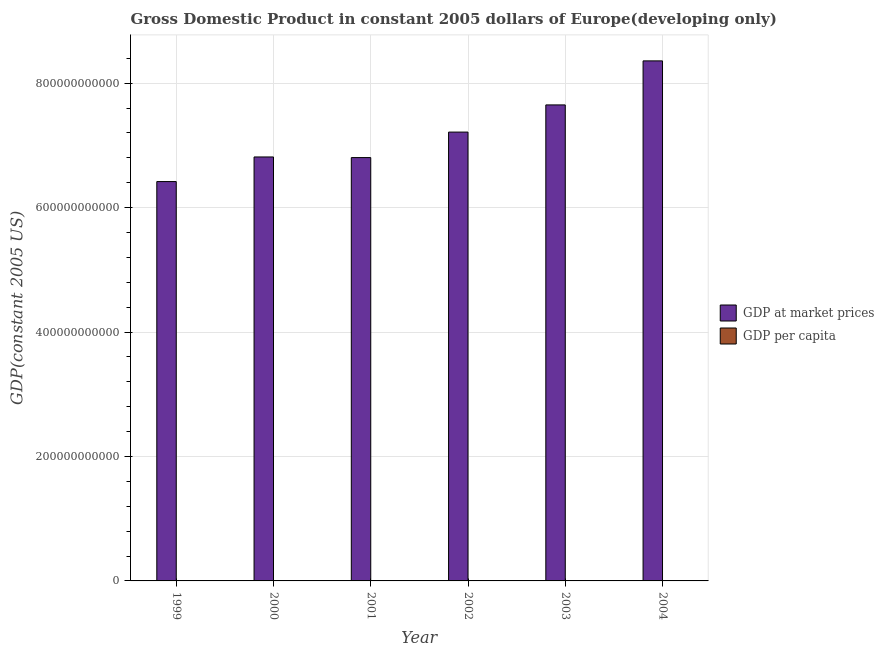How many groups of bars are there?
Keep it short and to the point. 6. Are the number of bars per tick equal to the number of legend labels?
Offer a terse response. Yes. Are the number of bars on each tick of the X-axis equal?
Offer a terse response. Yes. What is the label of the 1st group of bars from the left?
Your answer should be very brief. 1999. In how many cases, is the number of bars for a given year not equal to the number of legend labels?
Ensure brevity in your answer.  0. What is the gdp at market prices in 2003?
Offer a terse response. 7.65e+11. Across all years, what is the maximum gdp per capita?
Ensure brevity in your answer.  3361.42. Across all years, what is the minimum gdp per capita?
Offer a very short reply. 2616.8. In which year was the gdp per capita minimum?
Your answer should be very brief. 1999. What is the total gdp per capita in the graph?
Keep it short and to the point. 1.75e+04. What is the difference between the gdp per capita in 2001 and that in 2003?
Provide a short and direct response. -328.14. What is the difference between the gdp at market prices in 2000 and the gdp per capita in 2003?
Give a very brief answer. -8.37e+1. What is the average gdp at market prices per year?
Offer a very short reply. 7.21e+11. In the year 2003, what is the difference between the gdp at market prices and gdp per capita?
Your answer should be very brief. 0. What is the ratio of the gdp per capita in 2000 to that in 2003?
Keep it short and to the point. 0.9. Is the gdp at market prices in 1999 less than that in 2003?
Offer a terse response. Yes. Is the difference between the gdp at market prices in 2001 and 2002 greater than the difference between the gdp per capita in 2001 and 2002?
Make the answer very short. No. What is the difference between the highest and the second highest gdp at market prices?
Your answer should be compact. 7.08e+1. What is the difference between the highest and the lowest gdp per capita?
Provide a short and direct response. 744.62. In how many years, is the gdp at market prices greater than the average gdp at market prices taken over all years?
Your response must be concise. 3. Is the sum of the gdp per capita in 2000 and 2001 greater than the maximum gdp at market prices across all years?
Give a very brief answer. Yes. What does the 2nd bar from the left in 2002 represents?
Ensure brevity in your answer.  GDP per capita. What does the 2nd bar from the right in 2001 represents?
Provide a short and direct response. GDP at market prices. Are all the bars in the graph horizontal?
Provide a short and direct response. No. What is the difference between two consecutive major ticks on the Y-axis?
Keep it short and to the point. 2.00e+11. How many legend labels are there?
Make the answer very short. 2. What is the title of the graph?
Offer a very short reply. Gross Domestic Product in constant 2005 dollars of Europe(developing only). What is the label or title of the Y-axis?
Your response must be concise. GDP(constant 2005 US). What is the GDP(constant 2005 US) of GDP at market prices in 1999?
Ensure brevity in your answer.  6.42e+11. What is the GDP(constant 2005 US) in GDP per capita in 1999?
Your response must be concise. 2616.8. What is the GDP(constant 2005 US) of GDP at market prices in 2000?
Give a very brief answer. 6.81e+11. What is the GDP(constant 2005 US) of GDP per capita in 2000?
Your response must be concise. 2769.43. What is the GDP(constant 2005 US) in GDP at market prices in 2001?
Ensure brevity in your answer.  6.80e+11. What is the GDP(constant 2005 US) in GDP per capita in 2001?
Offer a terse response. 2761.01. What is the GDP(constant 2005 US) in GDP at market prices in 2002?
Your answer should be compact. 7.21e+11. What is the GDP(constant 2005 US) in GDP per capita in 2002?
Offer a very short reply. 2922.78. What is the GDP(constant 2005 US) in GDP at market prices in 2003?
Your answer should be very brief. 7.65e+11. What is the GDP(constant 2005 US) in GDP per capita in 2003?
Your response must be concise. 3089.14. What is the GDP(constant 2005 US) in GDP at market prices in 2004?
Offer a terse response. 8.36e+11. What is the GDP(constant 2005 US) of GDP per capita in 2004?
Ensure brevity in your answer.  3361.42. Across all years, what is the maximum GDP(constant 2005 US) of GDP at market prices?
Your response must be concise. 8.36e+11. Across all years, what is the maximum GDP(constant 2005 US) of GDP per capita?
Make the answer very short. 3361.42. Across all years, what is the minimum GDP(constant 2005 US) of GDP at market prices?
Your response must be concise. 6.42e+11. Across all years, what is the minimum GDP(constant 2005 US) in GDP per capita?
Your answer should be very brief. 2616.8. What is the total GDP(constant 2005 US) in GDP at market prices in the graph?
Make the answer very short. 4.33e+12. What is the total GDP(constant 2005 US) of GDP per capita in the graph?
Provide a short and direct response. 1.75e+04. What is the difference between the GDP(constant 2005 US) in GDP at market prices in 1999 and that in 2000?
Offer a very short reply. -3.96e+1. What is the difference between the GDP(constant 2005 US) of GDP per capita in 1999 and that in 2000?
Keep it short and to the point. -152.63. What is the difference between the GDP(constant 2005 US) in GDP at market prices in 1999 and that in 2001?
Give a very brief answer. -3.86e+1. What is the difference between the GDP(constant 2005 US) in GDP per capita in 1999 and that in 2001?
Your answer should be compact. -144.2. What is the difference between the GDP(constant 2005 US) in GDP at market prices in 1999 and that in 2002?
Offer a very short reply. -7.95e+1. What is the difference between the GDP(constant 2005 US) in GDP per capita in 1999 and that in 2002?
Make the answer very short. -305.98. What is the difference between the GDP(constant 2005 US) of GDP at market prices in 1999 and that in 2003?
Provide a short and direct response. -1.23e+11. What is the difference between the GDP(constant 2005 US) of GDP per capita in 1999 and that in 2003?
Provide a succinct answer. -472.34. What is the difference between the GDP(constant 2005 US) in GDP at market prices in 1999 and that in 2004?
Make the answer very short. -1.94e+11. What is the difference between the GDP(constant 2005 US) in GDP per capita in 1999 and that in 2004?
Offer a terse response. -744.62. What is the difference between the GDP(constant 2005 US) of GDP at market prices in 2000 and that in 2001?
Ensure brevity in your answer.  1.00e+09. What is the difference between the GDP(constant 2005 US) in GDP per capita in 2000 and that in 2001?
Keep it short and to the point. 8.43. What is the difference between the GDP(constant 2005 US) in GDP at market prices in 2000 and that in 2002?
Give a very brief answer. -4.00e+1. What is the difference between the GDP(constant 2005 US) in GDP per capita in 2000 and that in 2002?
Ensure brevity in your answer.  -153.35. What is the difference between the GDP(constant 2005 US) in GDP at market prices in 2000 and that in 2003?
Your answer should be compact. -8.37e+1. What is the difference between the GDP(constant 2005 US) in GDP per capita in 2000 and that in 2003?
Ensure brevity in your answer.  -319.71. What is the difference between the GDP(constant 2005 US) of GDP at market prices in 2000 and that in 2004?
Give a very brief answer. -1.54e+11. What is the difference between the GDP(constant 2005 US) of GDP per capita in 2000 and that in 2004?
Keep it short and to the point. -591.99. What is the difference between the GDP(constant 2005 US) of GDP at market prices in 2001 and that in 2002?
Offer a very short reply. -4.10e+1. What is the difference between the GDP(constant 2005 US) in GDP per capita in 2001 and that in 2002?
Ensure brevity in your answer.  -161.77. What is the difference between the GDP(constant 2005 US) of GDP at market prices in 2001 and that in 2003?
Provide a succinct answer. -8.47e+1. What is the difference between the GDP(constant 2005 US) in GDP per capita in 2001 and that in 2003?
Provide a short and direct response. -328.14. What is the difference between the GDP(constant 2005 US) in GDP at market prices in 2001 and that in 2004?
Your answer should be very brief. -1.55e+11. What is the difference between the GDP(constant 2005 US) of GDP per capita in 2001 and that in 2004?
Offer a terse response. -600.41. What is the difference between the GDP(constant 2005 US) of GDP at market prices in 2002 and that in 2003?
Your answer should be compact. -4.37e+1. What is the difference between the GDP(constant 2005 US) in GDP per capita in 2002 and that in 2003?
Give a very brief answer. -166.37. What is the difference between the GDP(constant 2005 US) of GDP at market prices in 2002 and that in 2004?
Offer a very short reply. -1.14e+11. What is the difference between the GDP(constant 2005 US) in GDP per capita in 2002 and that in 2004?
Make the answer very short. -438.64. What is the difference between the GDP(constant 2005 US) in GDP at market prices in 2003 and that in 2004?
Offer a very short reply. -7.08e+1. What is the difference between the GDP(constant 2005 US) of GDP per capita in 2003 and that in 2004?
Your response must be concise. -272.27. What is the difference between the GDP(constant 2005 US) of GDP at market prices in 1999 and the GDP(constant 2005 US) of GDP per capita in 2000?
Ensure brevity in your answer.  6.42e+11. What is the difference between the GDP(constant 2005 US) in GDP at market prices in 1999 and the GDP(constant 2005 US) in GDP per capita in 2001?
Offer a terse response. 6.42e+11. What is the difference between the GDP(constant 2005 US) in GDP at market prices in 1999 and the GDP(constant 2005 US) in GDP per capita in 2002?
Your answer should be very brief. 6.42e+11. What is the difference between the GDP(constant 2005 US) of GDP at market prices in 1999 and the GDP(constant 2005 US) of GDP per capita in 2003?
Your response must be concise. 6.42e+11. What is the difference between the GDP(constant 2005 US) of GDP at market prices in 1999 and the GDP(constant 2005 US) of GDP per capita in 2004?
Your answer should be very brief. 6.42e+11. What is the difference between the GDP(constant 2005 US) in GDP at market prices in 2000 and the GDP(constant 2005 US) in GDP per capita in 2001?
Offer a terse response. 6.81e+11. What is the difference between the GDP(constant 2005 US) of GDP at market prices in 2000 and the GDP(constant 2005 US) of GDP per capita in 2002?
Provide a succinct answer. 6.81e+11. What is the difference between the GDP(constant 2005 US) of GDP at market prices in 2000 and the GDP(constant 2005 US) of GDP per capita in 2003?
Provide a succinct answer. 6.81e+11. What is the difference between the GDP(constant 2005 US) of GDP at market prices in 2000 and the GDP(constant 2005 US) of GDP per capita in 2004?
Provide a succinct answer. 6.81e+11. What is the difference between the GDP(constant 2005 US) in GDP at market prices in 2001 and the GDP(constant 2005 US) in GDP per capita in 2002?
Keep it short and to the point. 6.80e+11. What is the difference between the GDP(constant 2005 US) of GDP at market prices in 2001 and the GDP(constant 2005 US) of GDP per capita in 2003?
Your response must be concise. 6.80e+11. What is the difference between the GDP(constant 2005 US) in GDP at market prices in 2001 and the GDP(constant 2005 US) in GDP per capita in 2004?
Provide a succinct answer. 6.80e+11. What is the difference between the GDP(constant 2005 US) in GDP at market prices in 2002 and the GDP(constant 2005 US) in GDP per capita in 2003?
Give a very brief answer. 7.21e+11. What is the difference between the GDP(constant 2005 US) of GDP at market prices in 2002 and the GDP(constant 2005 US) of GDP per capita in 2004?
Ensure brevity in your answer.  7.21e+11. What is the difference between the GDP(constant 2005 US) in GDP at market prices in 2003 and the GDP(constant 2005 US) in GDP per capita in 2004?
Make the answer very short. 7.65e+11. What is the average GDP(constant 2005 US) of GDP at market prices per year?
Make the answer very short. 7.21e+11. What is the average GDP(constant 2005 US) in GDP per capita per year?
Your answer should be very brief. 2920.1. In the year 1999, what is the difference between the GDP(constant 2005 US) in GDP at market prices and GDP(constant 2005 US) in GDP per capita?
Your answer should be compact. 6.42e+11. In the year 2000, what is the difference between the GDP(constant 2005 US) of GDP at market prices and GDP(constant 2005 US) of GDP per capita?
Give a very brief answer. 6.81e+11. In the year 2001, what is the difference between the GDP(constant 2005 US) of GDP at market prices and GDP(constant 2005 US) of GDP per capita?
Keep it short and to the point. 6.80e+11. In the year 2002, what is the difference between the GDP(constant 2005 US) in GDP at market prices and GDP(constant 2005 US) in GDP per capita?
Ensure brevity in your answer.  7.21e+11. In the year 2003, what is the difference between the GDP(constant 2005 US) of GDP at market prices and GDP(constant 2005 US) of GDP per capita?
Your response must be concise. 7.65e+11. In the year 2004, what is the difference between the GDP(constant 2005 US) in GDP at market prices and GDP(constant 2005 US) in GDP per capita?
Provide a short and direct response. 8.36e+11. What is the ratio of the GDP(constant 2005 US) in GDP at market prices in 1999 to that in 2000?
Your answer should be very brief. 0.94. What is the ratio of the GDP(constant 2005 US) in GDP per capita in 1999 to that in 2000?
Your response must be concise. 0.94. What is the ratio of the GDP(constant 2005 US) in GDP at market prices in 1999 to that in 2001?
Ensure brevity in your answer.  0.94. What is the ratio of the GDP(constant 2005 US) in GDP per capita in 1999 to that in 2001?
Your answer should be compact. 0.95. What is the ratio of the GDP(constant 2005 US) of GDP at market prices in 1999 to that in 2002?
Your response must be concise. 0.89. What is the ratio of the GDP(constant 2005 US) of GDP per capita in 1999 to that in 2002?
Your answer should be compact. 0.9. What is the ratio of the GDP(constant 2005 US) in GDP at market prices in 1999 to that in 2003?
Ensure brevity in your answer.  0.84. What is the ratio of the GDP(constant 2005 US) in GDP per capita in 1999 to that in 2003?
Ensure brevity in your answer.  0.85. What is the ratio of the GDP(constant 2005 US) in GDP at market prices in 1999 to that in 2004?
Provide a succinct answer. 0.77. What is the ratio of the GDP(constant 2005 US) in GDP per capita in 1999 to that in 2004?
Give a very brief answer. 0.78. What is the ratio of the GDP(constant 2005 US) of GDP at market prices in 2000 to that in 2002?
Your answer should be very brief. 0.94. What is the ratio of the GDP(constant 2005 US) in GDP per capita in 2000 to that in 2002?
Ensure brevity in your answer.  0.95. What is the ratio of the GDP(constant 2005 US) in GDP at market prices in 2000 to that in 2003?
Offer a very short reply. 0.89. What is the ratio of the GDP(constant 2005 US) in GDP per capita in 2000 to that in 2003?
Make the answer very short. 0.9. What is the ratio of the GDP(constant 2005 US) of GDP at market prices in 2000 to that in 2004?
Make the answer very short. 0.82. What is the ratio of the GDP(constant 2005 US) of GDP per capita in 2000 to that in 2004?
Provide a succinct answer. 0.82. What is the ratio of the GDP(constant 2005 US) in GDP at market prices in 2001 to that in 2002?
Give a very brief answer. 0.94. What is the ratio of the GDP(constant 2005 US) in GDP per capita in 2001 to that in 2002?
Give a very brief answer. 0.94. What is the ratio of the GDP(constant 2005 US) in GDP at market prices in 2001 to that in 2003?
Offer a very short reply. 0.89. What is the ratio of the GDP(constant 2005 US) in GDP per capita in 2001 to that in 2003?
Provide a short and direct response. 0.89. What is the ratio of the GDP(constant 2005 US) of GDP at market prices in 2001 to that in 2004?
Ensure brevity in your answer.  0.81. What is the ratio of the GDP(constant 2005 US) of GDP per capita in 2001 to that in 2004?
Keep it short and to the point. 0.82. What is the ratio of the GDP(constant 2005 US) of GDP at market prices in 2002 to that in 2003?
Provide a short and direct response. 0.94. What is the ratio of the GDP(constant 2005 US) of GDP per capita in 2002 to that in 2003?
Offer a very short reply. 0.95. What is the ratio of the GDP(constant 2005 US) in GDP at market prices in 2002 to that in 2004?
Offer a very short reply. 0.86. What is the ratio of the GDP(constant 2005 US) in GDP per capita in 2002 to that in 2004?
Your answer should be very brief. 0.87. What is the ratio of the GDP(constant 2005 US) of GDP at market prices in 2003 to that in 2004?
Offer a terse response. 0.92. What is the ratio of the GDP(constant 2005 US) in GDP per capita in 2003 to that in 2004?
Offer a terse response. 0.92. What is the difference between the highest and the second highest GDP(constant 2005 US) in GDP at market prices?
Provide a short and direct response. 7.08e+1. What is the difference between the highest and the second highest GDP(constant 2005 US) of GDP per capita?
Keep it short and to the point. 272.27. What is the difference between the highest and the lowest GDP(constant 2005 US) in GDP at market prices?
Your answer should be very brief. 1.94e+11. What is the difference between the highest and the lowest GDP(constant 2005 US) of GDP per capita?
Give a very brief answer. 744.62. 